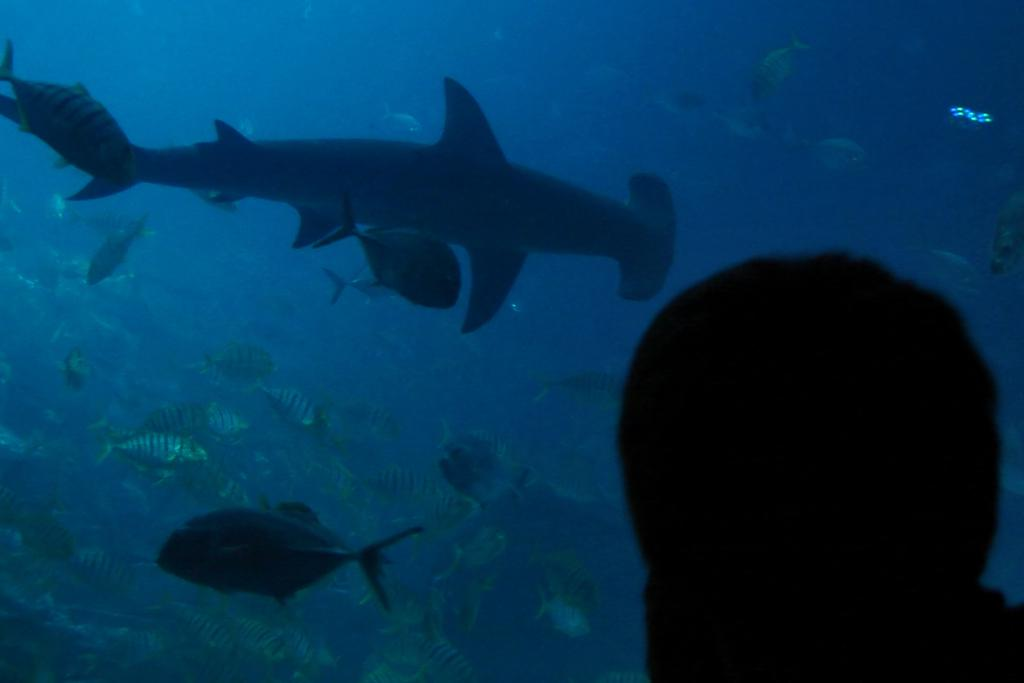What type of environment is depicted in the image? The image is an underwater scene. What kind of creatures can be seen in the image? There are aquatic animals in the image. What color is the water in the image? The water in the image is blue. Can you describe the black object visible in the image? There is a black object visible in the image, but its specific nature cannot be determined from the provided facts. How many icicles are hanging from the coral reef in the image? There are no icicles present in the image, as it is an underwater scene. What type of balloon can be seen floating in the water in the image? There are no balloons present in the image; it is an underwater scene with aquatic animals. 